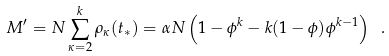Convert formula to latex. <formula><loc_0><loc_0><loc_500><loc_500>M ^ { \prime } = N \sum _ { \kappa = 2 } ^ { k } \rho _ { \kappa } ( t _ { * } ) = \alpha N \left ( 1 - \phi ^ { k } - k ( 1 - \phi ) \phi ^ { k - 1 } \right ) \ .</formula> 